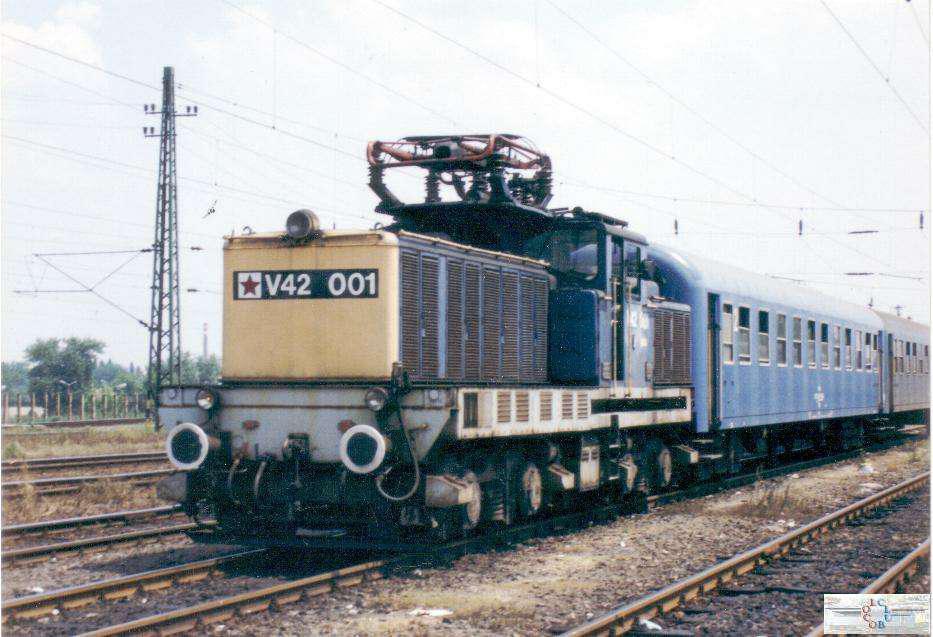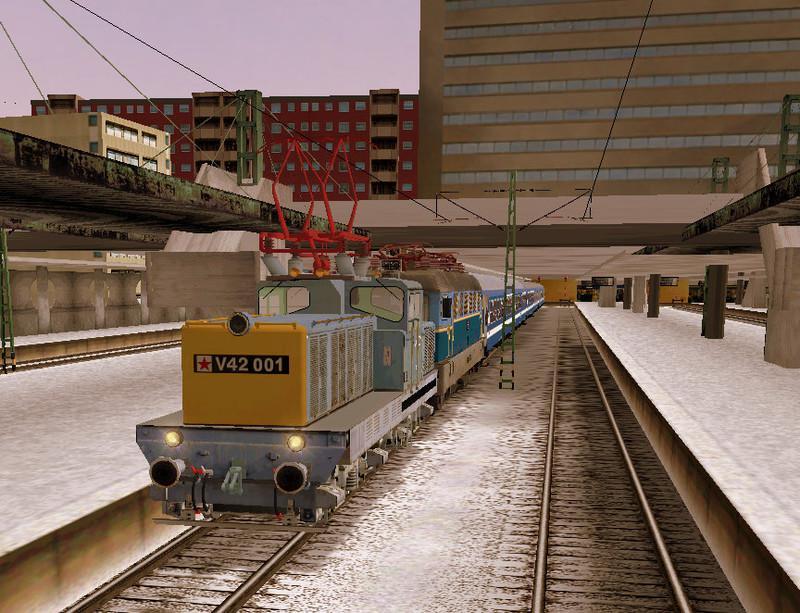The first image is the image on the left, the second image is the image on the right. Examine the images to the left and right. Is the description "An image shows a reddish-orange train facing rightward." accurate? Answer yes or no. No. 